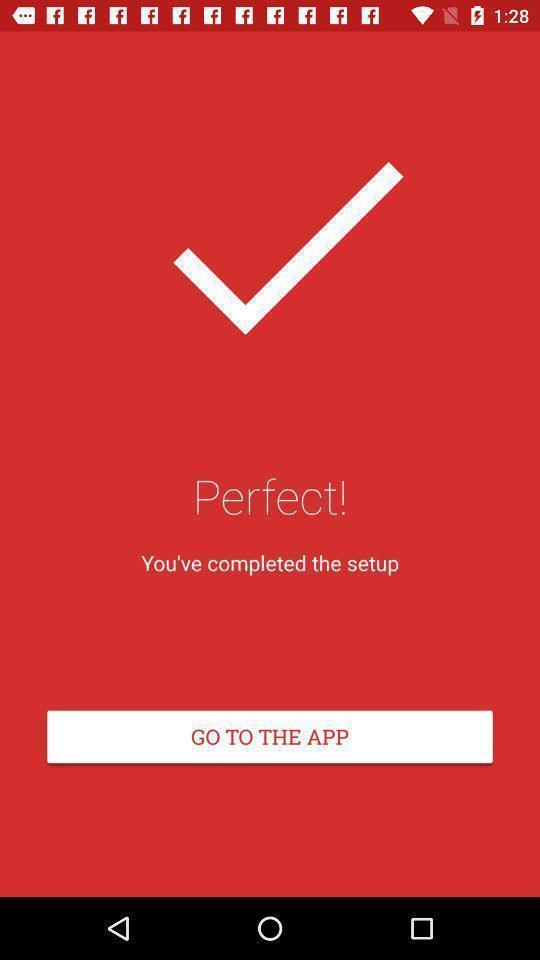Summarize the information in this screenshot. Page displaying the go to the app. 